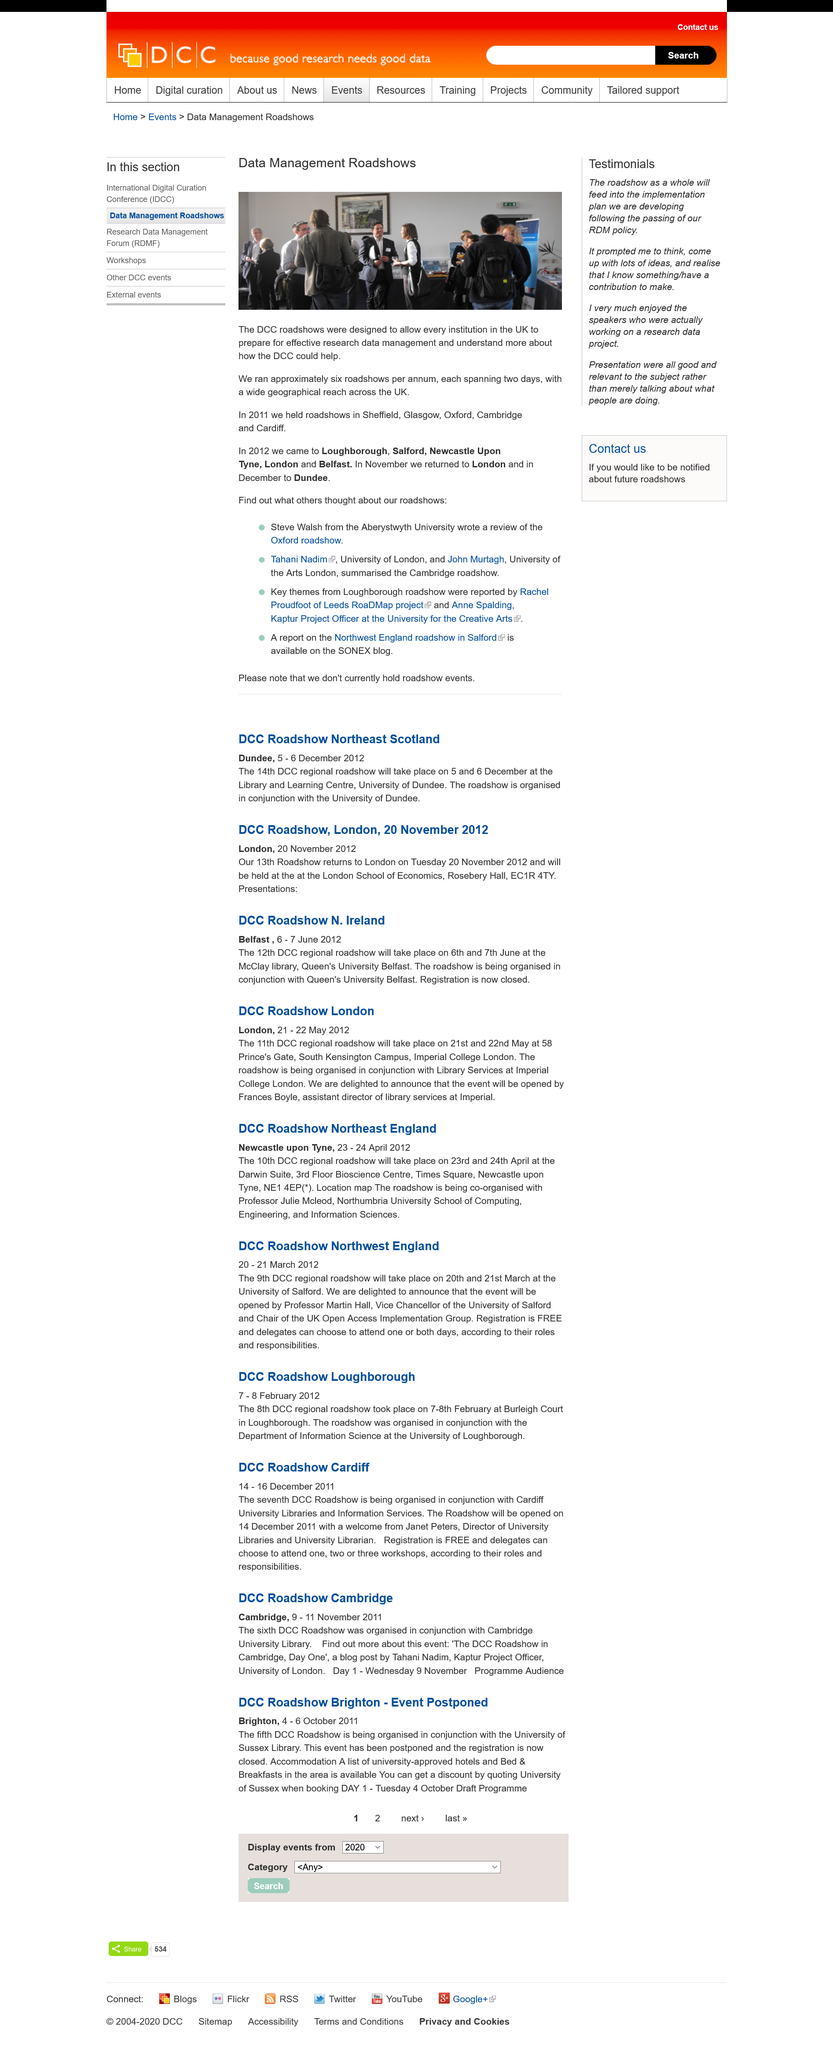Highlight a few significant elements in this photo. A roadshow was held in Belfast in 2012, and it was successful. Approximately six Data Management Roadshows were held annually. In 2011, the roadshows were held in Sheffield, Glasgow, Oxford, Cambridge, and Cardiff. 